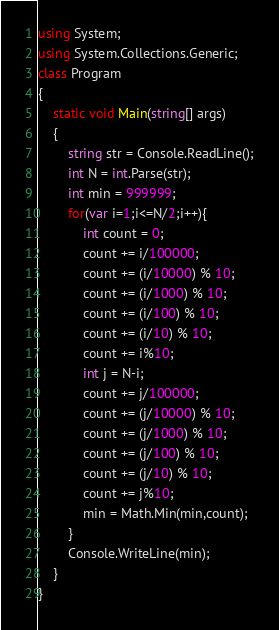<code> <loc_0><loc_0><loc_500><loc_500><_C#_>using System;
using System.Collections.Generic;
class Program
{
	static void Main(string[] args)
	{
		string str = Console.ReadLine();
		int N = int.Parse(str);
		int min = 999999;
		for(var i=1;i<=N/2;i++){
			int count = 0;
			count += i/100000;
			count += (i/10000) % 10;
			count += (i/1000) % 10;
			count += (i/100) % 10;
			count += (i/10) % 10;
			count += i%10;
			int j = N-i;
			count += j/100000;
			count += (j/10000) % 10;
			count += (j/1000) % 10;
			count += (j/100) % 10;
			count += (j/10) % 10;
			count += j%10;
			min = Math.Min(min,count);
		}
		Console.WriteLine(min);
	}
}</code> 